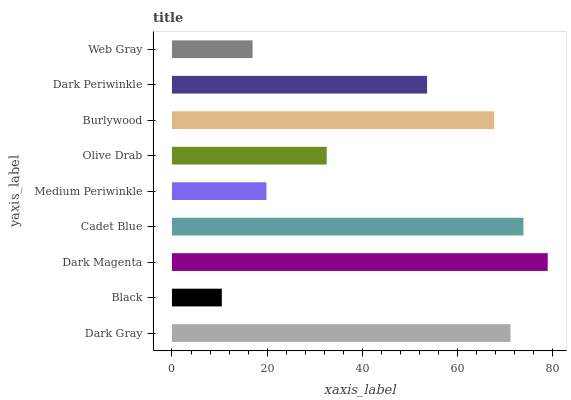Is Black the minimum?
Answer yes or no. Yes. Is Dark Magenta the maximum?
Answer yes or no. Yes. Is Dark Magenta the minimum?
Answer yes or no. No. Is Black the maximum?
Answer yes or no. No. Is Dark Magenta greater than Black?
Answer yes or no. Yes. Is Black less than Dark Magenta?
Answer yes or no. Yes. Is Black greater than Dark Magenta?
Answer yes or no. No. Is Dark Magenta less than Black?
Answer yes or no. No. Is Dark Periwinkle the high median?
Answer yes or no. Yes. Is Dark Periwinkle the low median?
Answer yes or no. Yes. Is Web Gray the high median?
Answer yes or no. No. Is Medium Periwinkle the low median?
Answer yes or no. No. 